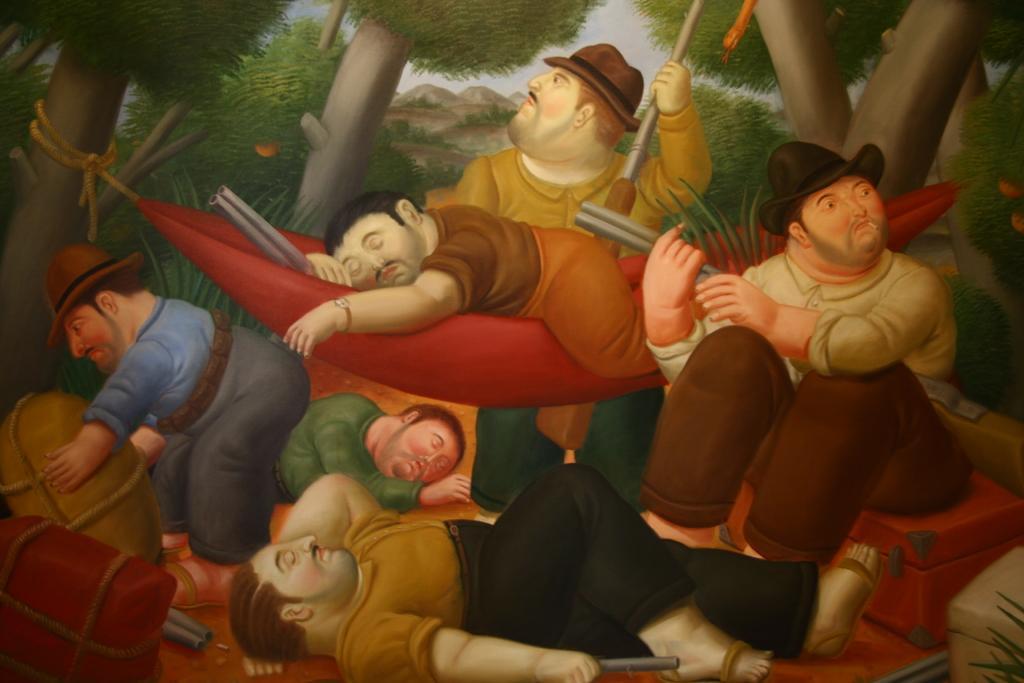Describe this image in one or two sentences. In this picture we can see a few people are lying on the path. A person is sitting on the box on the right side. We can see a person holding a box on the left side. There is a red box. We can see a few trees in the background. 